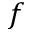Convert formula to latex. <formula><loc_0><loc_0><loc_500><loc_500>f</formula> 